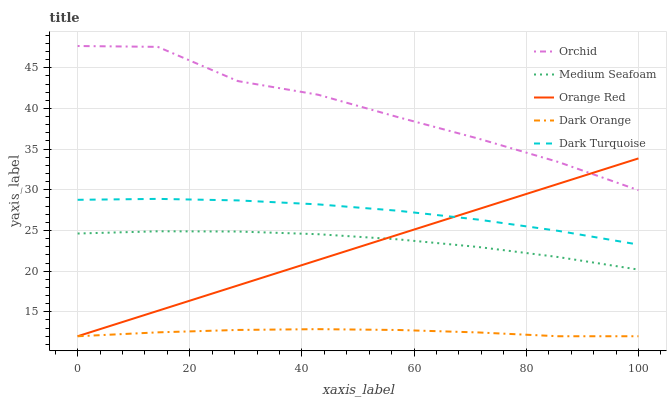Does Dark Orange have the minimum area under the curve?
Answer yes or no. Yes. Does Orchid have the maximum area under the curve?
Answer yes or no. Yes. Does Dark Turquoise have the minimum area under the curve?
Answer yes or no. No. Does Dark Turquoise have the maximum area under the curve?
Answer yes or no. No. Is Orange Red the smoothest?
Answer yes or no. Yes. Is Orchid the roughest?
Answer yes or no. Yes. Is Dark Turquoise the smoothest?
Answer yes or no. No. Is Dark Turquoise the roughest?
Answer yes or no. No. Does Dark Orange have the lowest value?
Answer yes or no. Yes. Does Dark Turquoise have the lowest value?
Answer yes or no. No. Does Orchid have the highest value?
Answer yes or no. Yes. Does Dark Turquoise have the highest value?
Answer yes or no. No. Is Medium Seafoam less than Dark Turquoise?
Answer yes or no. Yes. Is Orchid greater than Dark Turquoise?
Answer yes or no. Yes. Does Dark Turquoise intersect Orange Red?
Answer yes or no. Yes. Is Dark Turquoise less than Orange Red?
Answer yes or no. No. Is Dark Turquoise greater than Orange Red?
Answer yes or no. No. Does Medium Seafoam intersect Dark Turquoise?
Answer yes or no. No. 